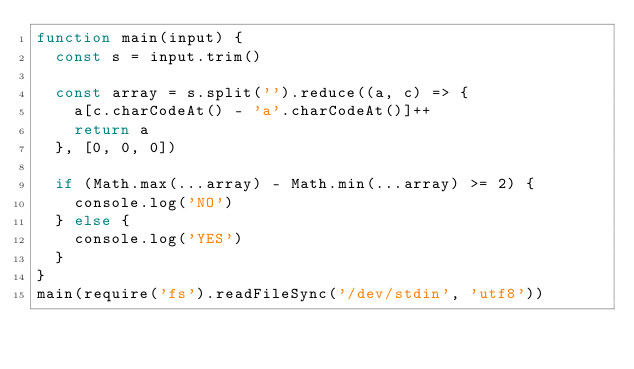Convert code to text. <code><loc_0><loc_0><loc_500><loc_500><_JavaScript_>function main(input) {
  const s = input.trim()

  const array = s.split('').reduce((a, c) => {
    a[c.charCodeAt() - 'a'.charCodeAt()]++
    return a
  }, [0, 0, 0])

  if (Math.max(...array) - Math.min(...array) >= 2) {
    console.log('NO')
  } else {
    console.log('YES')
  }
}
main(require('fs').readFileSync('/dev/stdin', 'utf8'))
</code> 